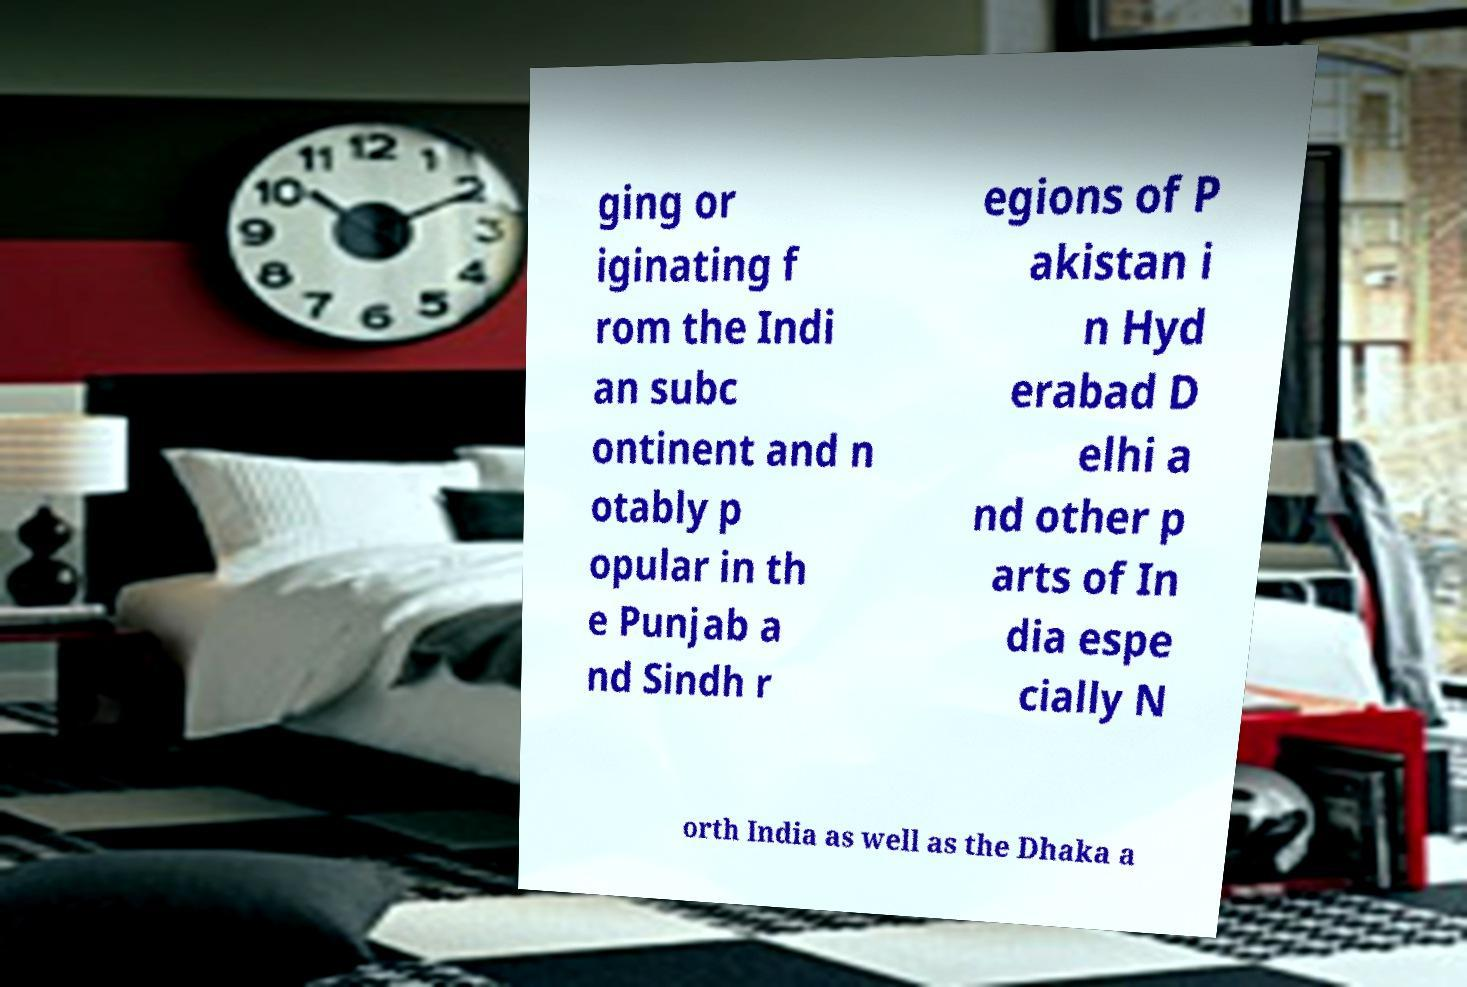There's text embedded in this image that I need extracted. Can you transcribe it verbatim? ging or iginating f rom the Indi an subc ontinent and n otably p opular in th e Punjab a nd Sindh r egions of P akistan i n Hyd erabad D elhi a nd other p arts of In dia espe cially N orth India as well as the Dhaka a 